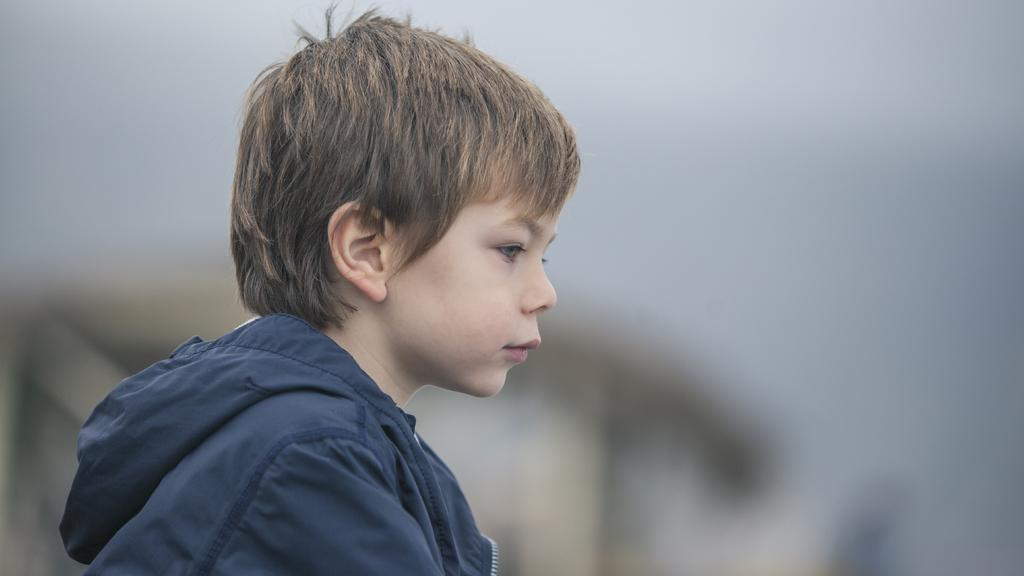Who is the main subject in the picture? There is a boy in the picture. What is the boy wearing? The boy is wearing a blue hoodie. Where is the boy positioned in the picture? The boy is in the middle of the picture. Can you describe the background of the image? The background of the image is blurred. What type of prose is the boy reading in the picture? There is no indication in the image that the boy is reading any prose, as he is not holding or interacting with any text. 